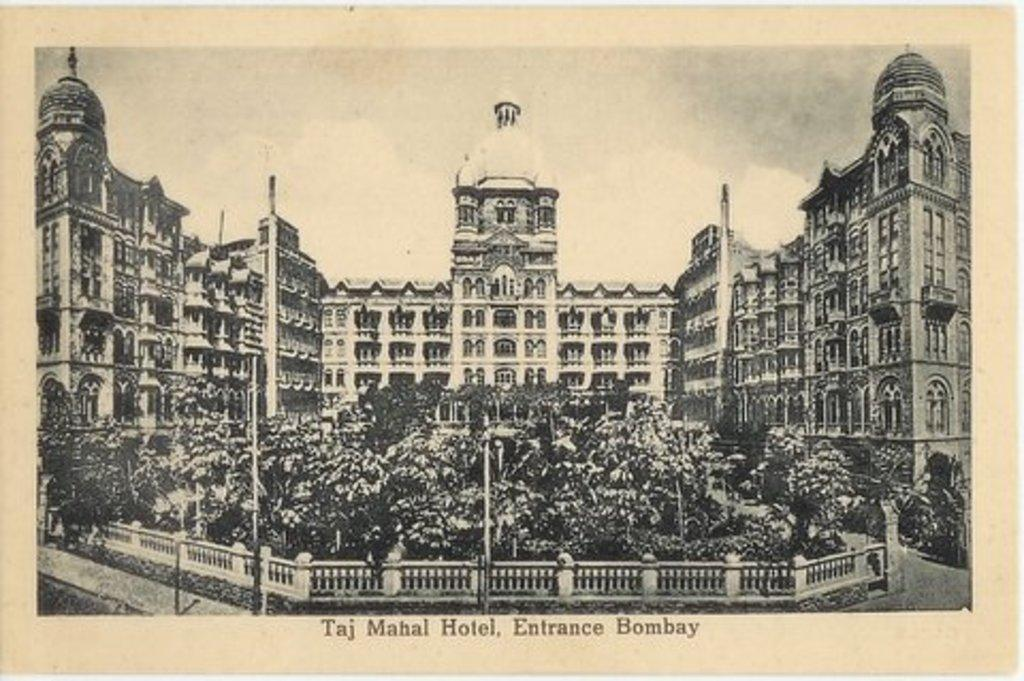What is the main structure visible in the image? There is a building in the image. What is located in front of the building? There are trees and poles in front of the building. Is there any text associated with the image? Yes, there is text written below the image. How does the beginner use the comb in the image? There is no beginner or comb present in the image. 